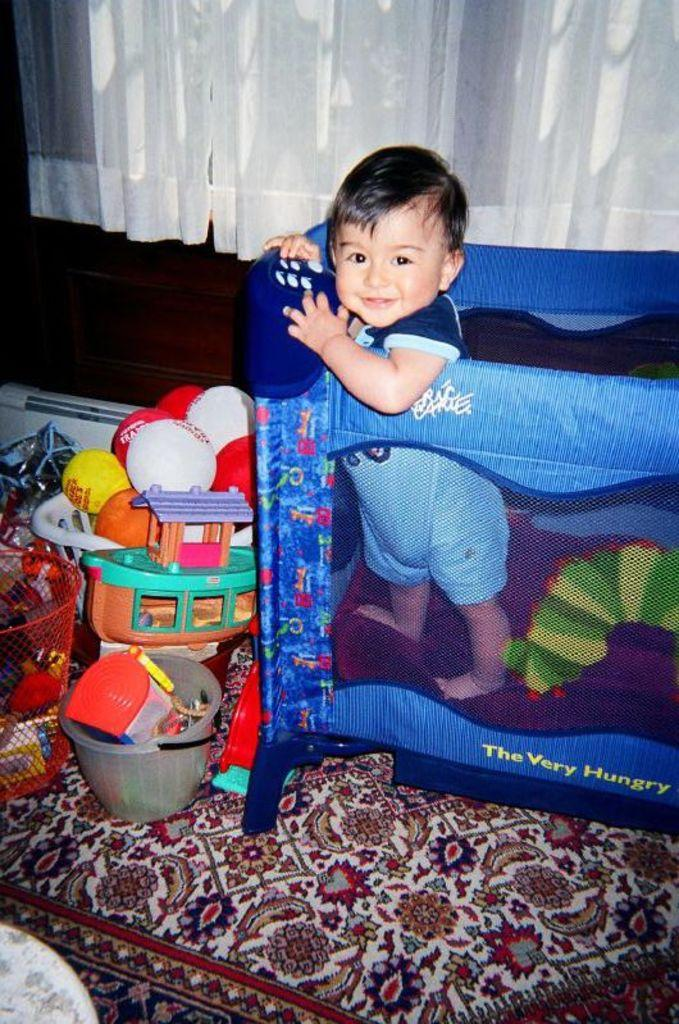What is the main subject of the image? There is a little boy in the cradle. What can be seen on the floor near the cradle? There are toys placed on the carpet in front of the cradle. What is visible in the background of the image? There is a curtain in the background of the image. How many ants are crawling on the van in the image? There is no van or ants present in the image. 